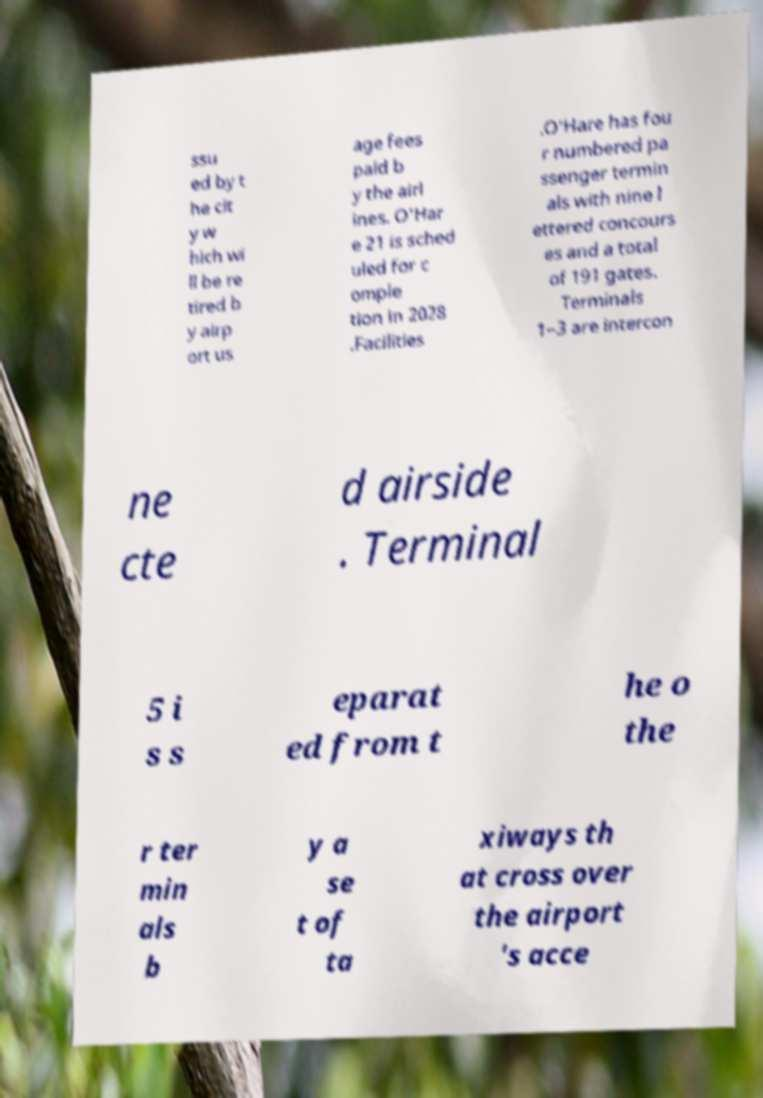I need the written content from this picture converted into text. Can you do that? ssu ed by t he cit y w hich wi ll be re tired b y airp ort us age fees paid b y the airl ines. O'Har e 21 is sched uled for c omple tion in 2028 .Facilities .O'Hare has fou r numbered pa ssenger termin als with nine l ettered concours es and a total of 191 gates. Terminals 1–3 are intercon ne cte d airside . Terminal 5 i s s eparat ed from t he o the r ter min als b y a se t of ta xiways th at cross over the airport 's acce 